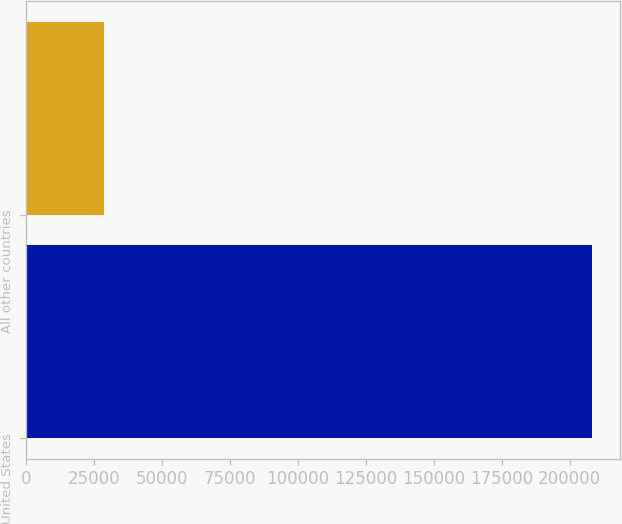Convert chart. <chart><loc_0><loc_0><loc_500><loc_500><bar_chart><fcel>United States<fcel>All other countries<nl><fcel>208190<fcel>28630<nl></chart> 